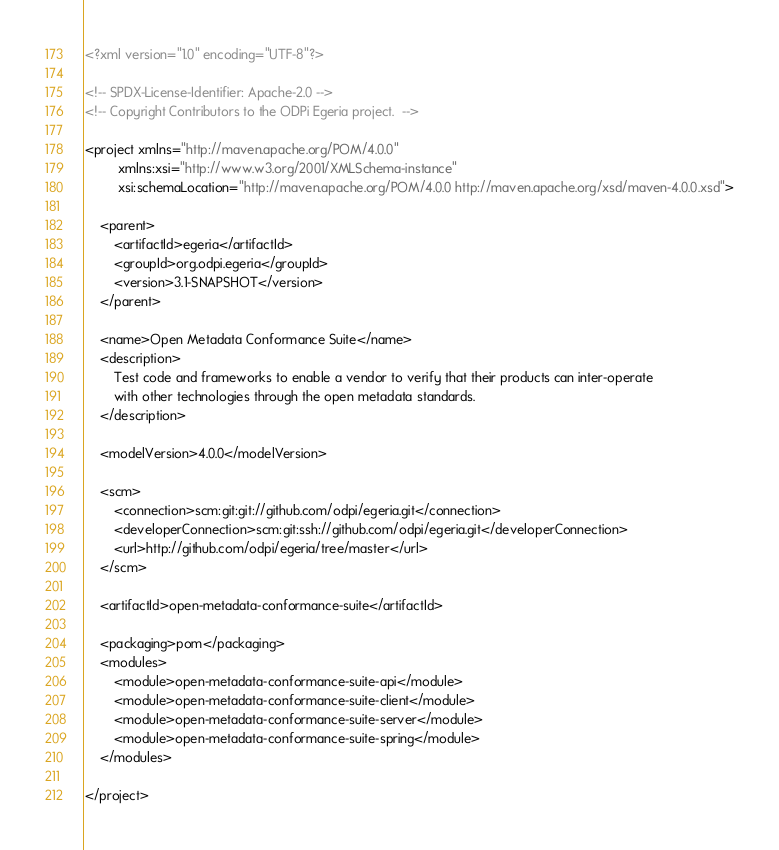Convert code to text. <code><loc_0><loc_0><loc_500><loc_500><_XML_><?xml version="1.0" encoding="UTF-8"?>

<!-- SPDX-License-Identifier: Apache-2.0 -->
<!-- Copyright Contributors to the ODPi Egeria project.  -->

<project xmlns="http://maven.apache.org/POM/4.0.0"
         xmlns:xsi="http://www.w3.org/2001/XMLSchema-instance"
         xsi:schemaLocation="http://maven.apache.org/POM/4.0.0 http://maven.apache.org/xsd/maven-4.0.0.xsd">

    <parent>
        <artifactId>egeria</artifactId>
        <groupId>org.odpi.egeria</groupId>
        <version>3.1-SNAPSHOT</version>
    </parent>

    <name>Open Metadata Conformance Suite</name>
    <description>
        Test code and frameworks to enable a vendor to verify that their products can inter-operate
        with other technologies through the open metadata standards.
    </description>

    <modelVersion>4.0.0</modelVersion>

    <scm>
        <connection>scm:git:git://github.com/odpi/egeria.git</connection>
        <developerConnection>scm:git:ssh://github.com/odpi/egeria.git</developerConnection>
        <url>http://github.com/odpi/egeria/tree/master</url>
    </scm>

    <artifactId>open-metadata-conformance-suite</artifactId>

    <packaging>pom</packaging>
    <modules>
        <module>open-metadata-conformance-suite-api</module>
        <module>open-metadata-conformance-suite-client</module>
        <module>open-metadata-conformance-suite-server</module>
        <module>open-metadata-conformance-suite-spring</module>
    </modules>

</project>
</code> 